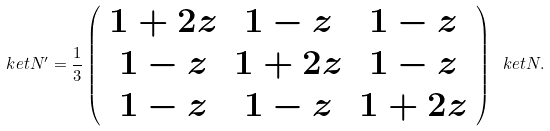Convert formula to latex. <formula><loc_0><loc_0><loc_500><loc_500>\ k e t { N ^ { \prime } } = \frac { 1 } { 3 } \left ( \begin{array} { c c c } 1 + 2 z & 1 - z & 1 - z \\ 1 - z & 1 + 2 z & 1 - z \\ 1 - z & 1 - z & 1 + 2 z \end{array} \right ) \ k e t { N } .</formula> 